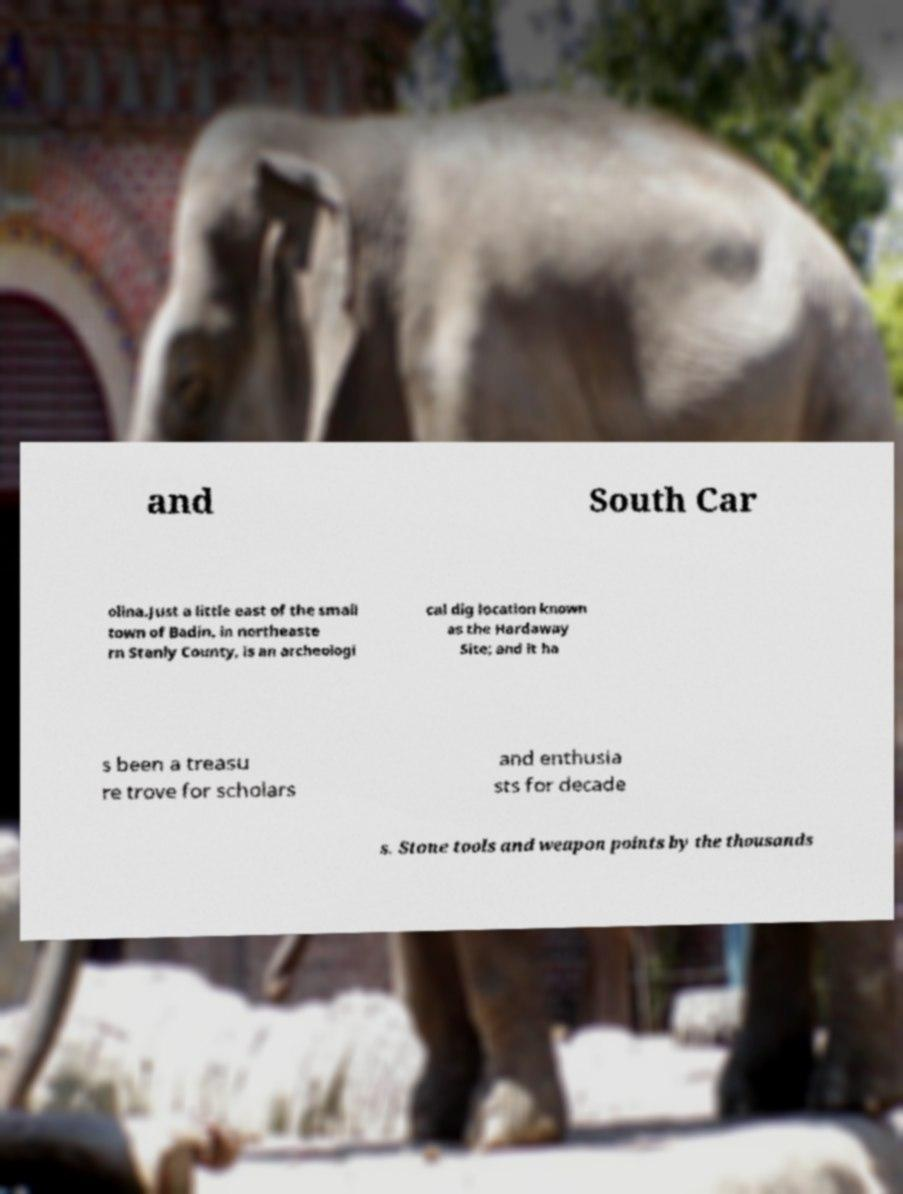Please read and relay the text visible in this image. What does it say? and South Car olina.Just a little east of the small town of Badin, in northeaste rn Stanly County, is an archeologi cal dig location known as the Hardaway Site; and it ha s been a treasu re trove for scholars and enthusia sts for decade s. Stone tools and weapon points by the thousands 